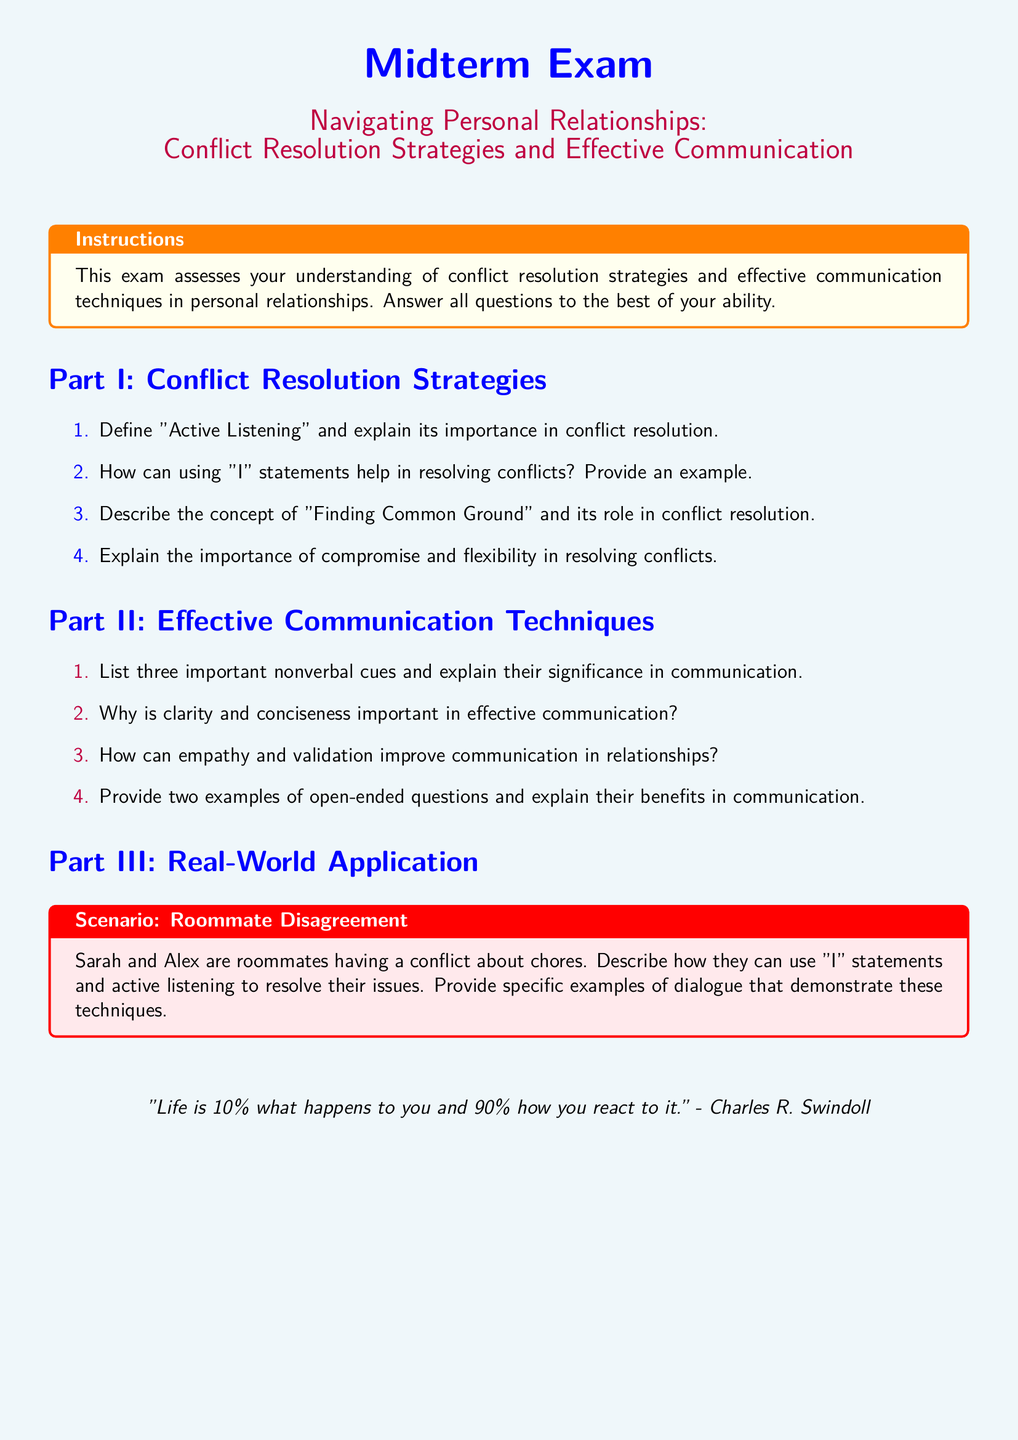What is the title of the exam? The title of the exam is explicitly stated at the top of the document.
Answer: Navigating Personal Relationships: Conflict Resolution Strategies and Effective Communication What are the two parts of the exam? The document outlines two main sections that structure the exam content.
Answer: Part I and Part II How many nonverbal cues are listed in Part II? The document specifically requests three important nonverbal cues in Part II.
Answer: Three What color is the background of the document? The document describes the background color used throughout it.
Answer: Light blue What is the main focus of the Scenario section? The scenario section presents a specific context for applying conflict resolution strategies.
Answer: Roommate Disagreement What does the quote at the end of the document convey? The quote summarizes the main theme related to perspective and reaction to events.
Answer: Perspective on reaction What type of questions are asked in Part III? The type of questions in Part III require practical application of the strategies discussed in the exam.
Answer: Real-World Application What is a suggested method to resolve conflicts according to Part I? One of the suggested methods mentioned emphasizes communication techniques in resolution.
Answer: Active Listening 